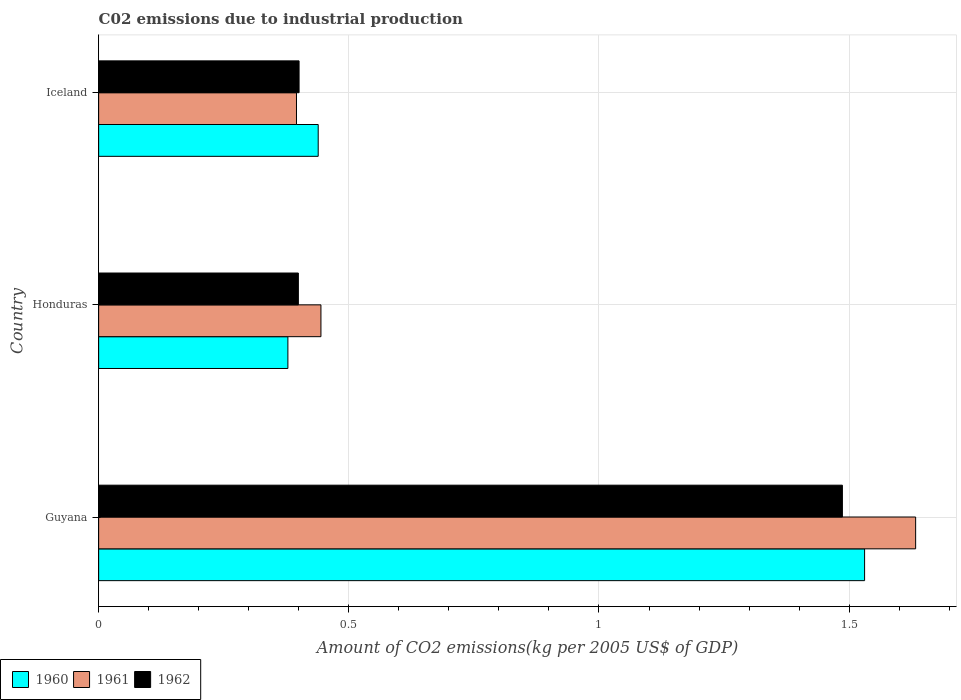Are the number of bars on each tick of the Y-axis equal?
Give a very brief answer. Yes. How many bars are there on the 3rd tick from the top?
Your response must be concise. 3. What is the label of the 3rd group of bars from the top?
Offer a terse response. Guyana. What is the amount of CO2 emitted due to industrial production in 1960 in Honduras?
Your response must be concise. 0.38. Across all countries, what is the maximum amount of CO2 emitted due to industrial production in 1962?
Ensure brevity in your answer.  1.49. Across all countries, what is the minimum amount of CO2 emitted due to industrial production in 1960?
Your response must be concise. 0.38. In which country was the amount of CO2 emitted due to industrial production in 1960 maximum?
Make the answer very short. Guyana. In which country was the amount of CO2 emitted due to industrial production in 1961 minimum?
Offer a terse response. Iceland. What is the total amount of CO2 emitted due to industrial production in 1960 in the graph?
Offer a very short reply. 2.35. What is the difference between the amount of CO2 emitted due to industrial production in 1961 in Guyana and that in Honduras?
Ensure brevity in your answer.  1.19. What is the difference between the amount of CO2 emitted due to industrial production in 1960 in Guyana and the amount of CO2 emitted due to industrial production in 1962 in Iceland?
Your response must be concise. 1.13. What is the average amount of CO2 emitted due to industrial production in 1962 per country?
Offer a terse response. 0.76. What is the difference between the amount of CO2 emitted due to industrial production in 1962 and amount of CO2 emitted due to industrial production in 1961 in Guyana?
Your answer should be very brief. -0.15. In how many countries, is the amount of CO2 emitted due to industrial production in 1962 greater than 0.8 kg?
Offer a very short reply. 1. What is the ratio of the amount of CO2 emitted due to industrial production in 1962 in Guyana to that in Iceland?
Your answer should be compact. 3.71. Is the amount of CO2 emitted due to industrial production in 1961 in Guyana less than that in Iceland?
Make the answer very short. No. What is the difference between the highest and the second highest amount of CO2 emitted due to industrial production in 1962?
Make the answer very short. 1.09. What is the difference between the highest and the lowest amount of CO2 emitted due to industrial production in 1961?
Offer a very short reply. 1.24. In how many countries, is the amount of CO2 emitted due to industrial production in 1961 greater than the average amount of CO2 emitted due to industrial production in 1961 taken over all countries?
Keep it short and to the point. 1. Is the sum of the amount of CO2 emitted due to industrial production in 1961 in Guyana and Iceland greater than the maximum amount of CO2 emitted due to industrial production in 1962 across all countries?
Give a very brief answer. Yes. What does the 3rd bar from the top in Honduras represents?
Keep it short and to the point. 1960. What does the 3rd bar from the bottom in Guyana represents?
Your answer should be very brief. 1962. Is it the case that in every country, the sum of the amount of CO2 emitted due to industrial production in 1961 and amount of CO2 emitted due to industrial production in 1962 is greater than the amount of CO2 emitted due to industrial production in 1960?
Provide a short and direct response. Yes. Are all the bars in the graph horizontal?
Provide a succinct answer. Yes. Does the graph contain any zero values?
Offer a very short reply. No. Where does the legend appear in the graph?
Your response must be concise. Bottom left. How many legend labels are there?
Ensure brevity in your answer.  3. What is the title of the graph?
Your response must be concise. C02 emissions due to industrial production. What is the label or title of the X-axis?
Make the answer very short. Amount of CO2 emissions(kg per 2005 US$ of GDP). What is the label or title of the Y-axis?
Provide a short and direct response. Country. What is the Amount of CO2 emissions(kg per 2005 US$ of GDP) in 1960 in Guyana?
Offer a very short reply. 1.53. What is the Amount of CO2 emissions(kg per 2005 US$ of GDP) in 1961 in Guyana?
Your answer should be compact. 1.63. What is the Amount of CO2 emissions(kg per 2005 US$ of GDP) of 1962 in Guyana?
Provide a short and direct response. 1.49. What is the Amount of CO2 emissions(kg per 2005 US$ of GDP) of 1960 in Honduras?
Ensure brevity in your answer.  0.38. What is the Amount of CO2 emissions(kg per 2005 US$ of GDP) of 1961 in Honduras?
Offer a very short reply. 0.44. What is the Amount of CO2 emissions(kg per 2005 US$ of GDP) of 1962 in Honduras?
Keep it short and to the point. 0.4. What is the Amount of CO2 emissions(kg per 2005 US$ of GDP) in 1960 in Iceland?
Ensure brevity in your answer.  0.44. What is the Amount of CO2 emissions(kg per 2005 US$ of GDP) in 1961 in Iceland?
Your answer should be very brief. 0.4. What is the Amount of CO2 emissions(kg per 2005 US$ of GDP) of 1962 in Iceland?
Your response must be concise. 0.4. Across all countries, what is the maximum Amount of CO2 emissions(kg per 2005 US$ of GDP) in 1960?
Offer a very short reply. 1.53. Across all countries, what is the maximum Amount of CO2 emissions(kg per 2005 US$ of GDP) of 1961?
Offer a very short reply. 1.63. Across all countries, what is the maximum Amount of CO2 emissions(kg per 2005 US$ of GDP) of 1962?
Make the answer very short. 1.49. Across all countries, what is the minimum Amount of CO2 emissions(kg per 2005 US$ of GDP) in 1960?
Provide a short and direct response. 0.38. Across all countries, what is the minimum Amount of CO2 emissions(kg per 2005 US$ of GDP) in 1961?
Keep it short and to the point. 0.4. Across all countries, what is the minimum Amount of CO2 emissions(kg per 2005 US$ of GDP) in 1962?
Make the answer very short. 0.4. What is the total Amount of CO2 emissions(kg per 2005 US$ of GDP) in 1960 in the graph?
Provide a succinct answer. 2.35. What is the total Amount of CO2 emissions(kg per 2005 US$ of GDP) of 1961 in the graph?
Provide a succinct answer. 2.47. What is the total Amount of CO2 emissions(kg per 2005 US$ of GDP) of 1962 in the graph?
Offer a very short reply. 2.29. What is the difference between the Amount of CO2 emissions(kg per 2005 US$ of GDP) of 1960 in Guyana and that in Honduras?
Give a very brief answer. 1.15. What is the difference between the Amount of CO2 emissions(kg per 2005 US$ of GDP) of 1961 in Guyana and that in Honduras?
Provide a short and direct response. 1.19. What is the difference between the Amount of CO2 emissions(kg per 2005 US$ of GDP) of 1962 in Guyana and that in Honduras?
Make the answer very short. 1.09. What is the difference between the Amount of CO2 emissions(kg per 2005 US$ of GDP) of 1960 in Guyana and that in Iceland?
Provide a succinct answer. 1.09. What is the difference between the Amount of CO2 emissions(kg per 2005 US$ of GDP) in 1961 in Guyana and that in Iceland?
Your answer should be compact. 1.24. What is the difference between the Amount of CO2 emissions(kg per 2005 US$ of GDP) in 1962 in Guyana and that in Iceland?
Provide a succinct answer. 1.09. What is the difference between the Amount of CO2 emissions(kg per 2005 US$ of GDP) in 1960 in Honduras and that in Iceland?
Your answer should be compact. -0.06. What is the difference between the Amount of CO2 emissions(kg per 2005 US$ of GDP) in 1961 in Honduras and that in Iceland?
Make the answer very short. 0.05. What is the difference between the Amount of CO2 emissions(kg per 2005 US$ of GDP) of 1962 in Honduras and that in Iceland?
Ensure brevity in your answer.  -0. What is the difference between the Amount of CO2 emissions(kg per 2005 US$ of GDP) of 1960 in Guyana and the Amount of CO2 emissions(kg per 2005 US$ of GDP) of 1961 in Honduras?
Your response must be concise. 1.09. What is the difference between the Amount of CO2 emissions(kg per 2005 US$ of GDP) of 1960 in Guyana and the Amount of CO2 emissions(kg per 2005 US$ of GDP) of 1962 in Honduras?
Give a very brief answer. 1.13. What is the difference between the Amount of CO2 emissions(kg per 2005 US$ of GDP) in 1961 in Guyana and the Amount of CO2 emissions(kg per 2005 US$ of GDP) in 1962 in Honduras?
Provide a succinct answer. 1.23. What is the difference between the Amount of CO2 emissions(kg per 2005 US$ of GDP) in 1960 in Guyana and the Amount of CO2 emissions(kg per 2005 US$ of GDP) in 1961 in Iceland?
Make the answer very short. 1.14. What is the difference between the Amount of CO2 emissions(kg per 2005 US$ of GDP) in 1960 in Guyana and the Amount of CO2 emissions(kg per 2005 US$ of GDP) in 1962 in Iceland?
Your response must be concise. 1.13. What is the difference between the Amount of CO2 emissions(kg per 2005 US$ of GDP) of 1961 in Guyana and the Amount of CO2 emissions(kg per 2005 US$ of GDP) of 1962 in Iceland?
Provide a succinct answer. 1.23. What is the difference between the Amount of CO2 emissions(kg per 2005 US$ of GDP) of 1960 in Honduras and the Amount of CO2 emissions(kg per 2005 US$ of GDP) of 1961 in Iceland?
Provide a short and direct response. -0.02. What is the difference between the Amount of CO2 emissions(kg per 2005 US$ of GDP) in 1960 in Honduras and the Amount of CO2 emissions(kg per 2005 US$ of GDP) in 1962 in Iceland?
Your response must be concise. -0.02. What is the difference between the Amount of CO2 emissions(kg per 2005 US$ of GDP) in 1961 in Honduras and the Amount of CO2 emissions(kg per 2005 US$ of GDP) in 1962 in Iceland?
Offer a very short reply. 0.04. What is the average Amount of CO2 emissions(kg per 2005 US$ of GDP) in 1960 per country?
Provide a short and direct response. 0.78. What is the average Amount of CO2 emissions(kg per 2005 US$ of GDP) in 1961 per country?
Offer a very short reply. 0.82. What is the average Amount of CO2 emissions(kg per 2005 US$ of GDP) in 1962 per country?
Make the answer very short. 0.76. What is the difference between the Amount of CO2 emissions(kg per 2005 US$ of GDP) in 1960 and Amount of CO2 emissions(kg per 2005 US$ of GDP) in 1961 in Guyana?
Keep it short and to the point. -0.1. What is the difference between the Amount of CO2 emissions(kg per 2005 US$ of GDP) in 1960 and Amount of CO2 emissions(kg per 2005 US$ of GDP) in 1962 in Guyana?
Ensure brevity in your answer.  0.04. What is the difference between the Amount of CO2 emissions(kg per 2005 US$ of GDP) of 1961 and Amount of CO2 emissions(kg per 2005 US$ of GDP) of 1962 in Guyana?
Your response must be concise. 0.15. What is the difference between the Amount of CO2 emissions(kg per 2005 US$ of GDP) of 1960 and Amount of CO2 emissions(kg per 2005 US$ of GDP) of 1961 in Honduras?
Your answer should be compact. -0.07. What is the difference between the Amount of CO2 emissions(kg per 2005 US$ of GDP) of 1960 and Amount of CO2 emissions(kg per 2005 US$ of GDP) of 1962 in Honduras?
Your response must be concise. -0.02. What is the difference between the Amount of CO2 emissions(kg per 2005 US$ of GDP) in 1961 and Amount of CO2 emissions(kg per 2005 US$ of GDP) in 1962 in Honduras?
Your answer should be very brief. 0.05. What is the difference between the Amount of CO2 emissions(kg per 2005 US$ of GDP) in 1960 and Amount of CO2 emissions(kg per 2005 US$ of GDP) in 1961 in Iceland?
Offer a terse response. 0.04. What is the difference between the Amount of CO2 emissions(kg per 2005 US$ of GDP) of 1960 and Amount of CO2 emissions(kg per 2005 US$ of GDP) of 1962 in Iceland?
Provide a short and direct response. 0.04. What is the difference between the Amount of CO2 emissions(kg per 2005 US$ of GDP) of 1961 and Amount of CO2 emissions(kg per 2005 US$ of GDP) of 1962 in Iceland?
Give a very brief answer. -0.01. What is the ratio of the Amount of CO2 emissions(kg per 2005 US$ of GDP) of 1960 in Guyana to that in Honduras?
Give a very brief answer. 4.05. What is the ratio of the Amount of CO2 emissions(kg per 2005 US$ of GDP) of 1961 in Guyana to that in Honduras?
Give a very brief answer. 3.68. What is the ratio of the Amount of CO2 emissions(kg per 2005 US$ of GDP) in 1962 in Guyana to that in Honduras?
Provide a short and direct response. 3.72. What is the ratio of the Amount of CO2 emissions(kg per 2005 US$ of GDP) in 1960 in Guyana to that in Iceland?
Provide a succinct answer. 3.49. What is the ratio of the Amount of CO2 emissions(kg per 2005 US$ of GDP) of 1961 in Guyana to that in Iceland?
Make the answer very short. 4.13. What is the ratio of the Amount of CO2 emissions(kg per 2005 US$ of GDP) in 1962 in Guyana to that in Iceland?
Offer a very short reply. 3.71. What is the ratio of the Amount of CO2 emissions(kg per 2005 US$ of GDP) of 1960 in Honduras to that in Iceland?
Offer a very short reply. 0.86. What is the ratio of the Amount of CO2 emissions(kg per 2005 US$ of GDP) in 1961 in Honduras to that in Iceland?
Offer a terse response. 1.12. What is the ratio of the Amount of CO2 emissions(kg per 2005 US$ of GDP) in 1962 in Honduras to that in Iceland?
Ensure brevity in your answer.  1. What is the difference between the highest and the second highest Amount of CO2 emissions(kg per 2005 US$ of GDP) in 1960?
Provide a short and direct response. 1.09. What is the difference between the highest and the second highest Amount of CO2 emissions(kg per 2005 US$ of GDP) of 1961?
Your answer should be very brief. 1.19. What is the difference between the highest and the second highest Amount of CO2 emissions(kg per 2005 US$ of GDP) of 1962?
Your answer should be very brief. 1.09. What is the difference between the highest and the lowest Amount of CO2 emissions(kg per 2005 US$ of GDP) in 1960?
Offer a very short reply. 1.15. What is the difference between the highest and the lowest Amount of CO2 emissions(kg per 2005 US$ of GDP) of 1961?
Offer a very short reply. 1.24. What is the difference between the highest and the lowest Amount of CO2 emissions(kg per 2005 US$ of GDP) in 1962?
Your response must be concise. 1.09. 